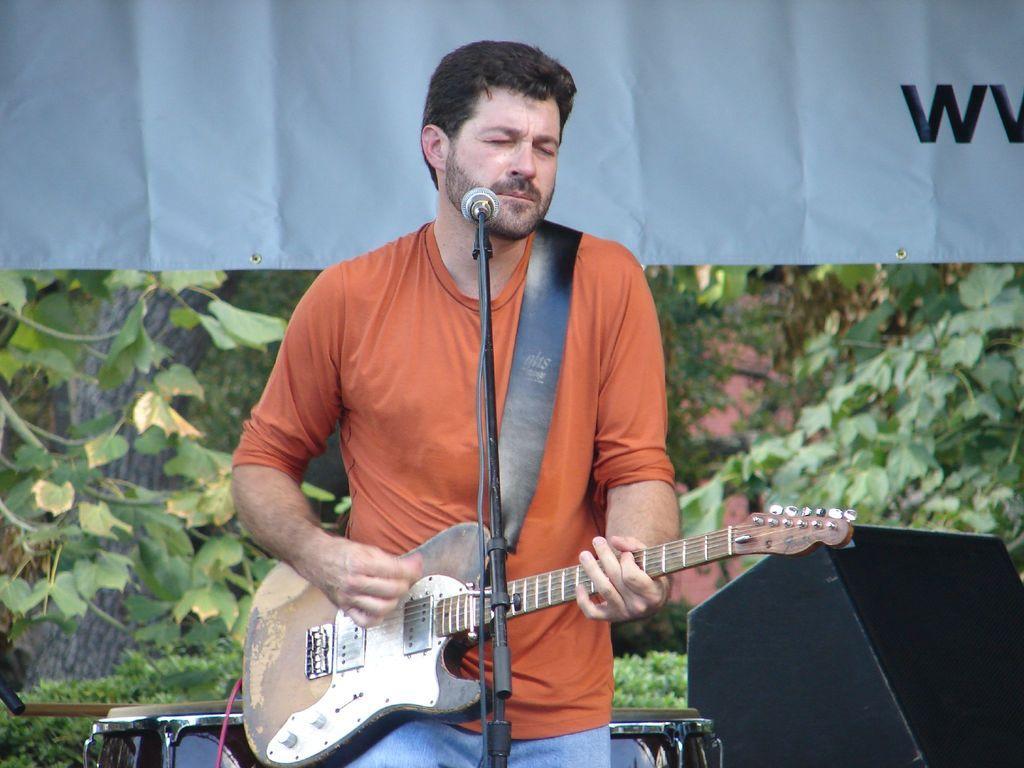Could you give a brief overview of what you see in this image? In this image there is a man standing and playing a guitar and the background there is drums , speaker , tree and a banner. 